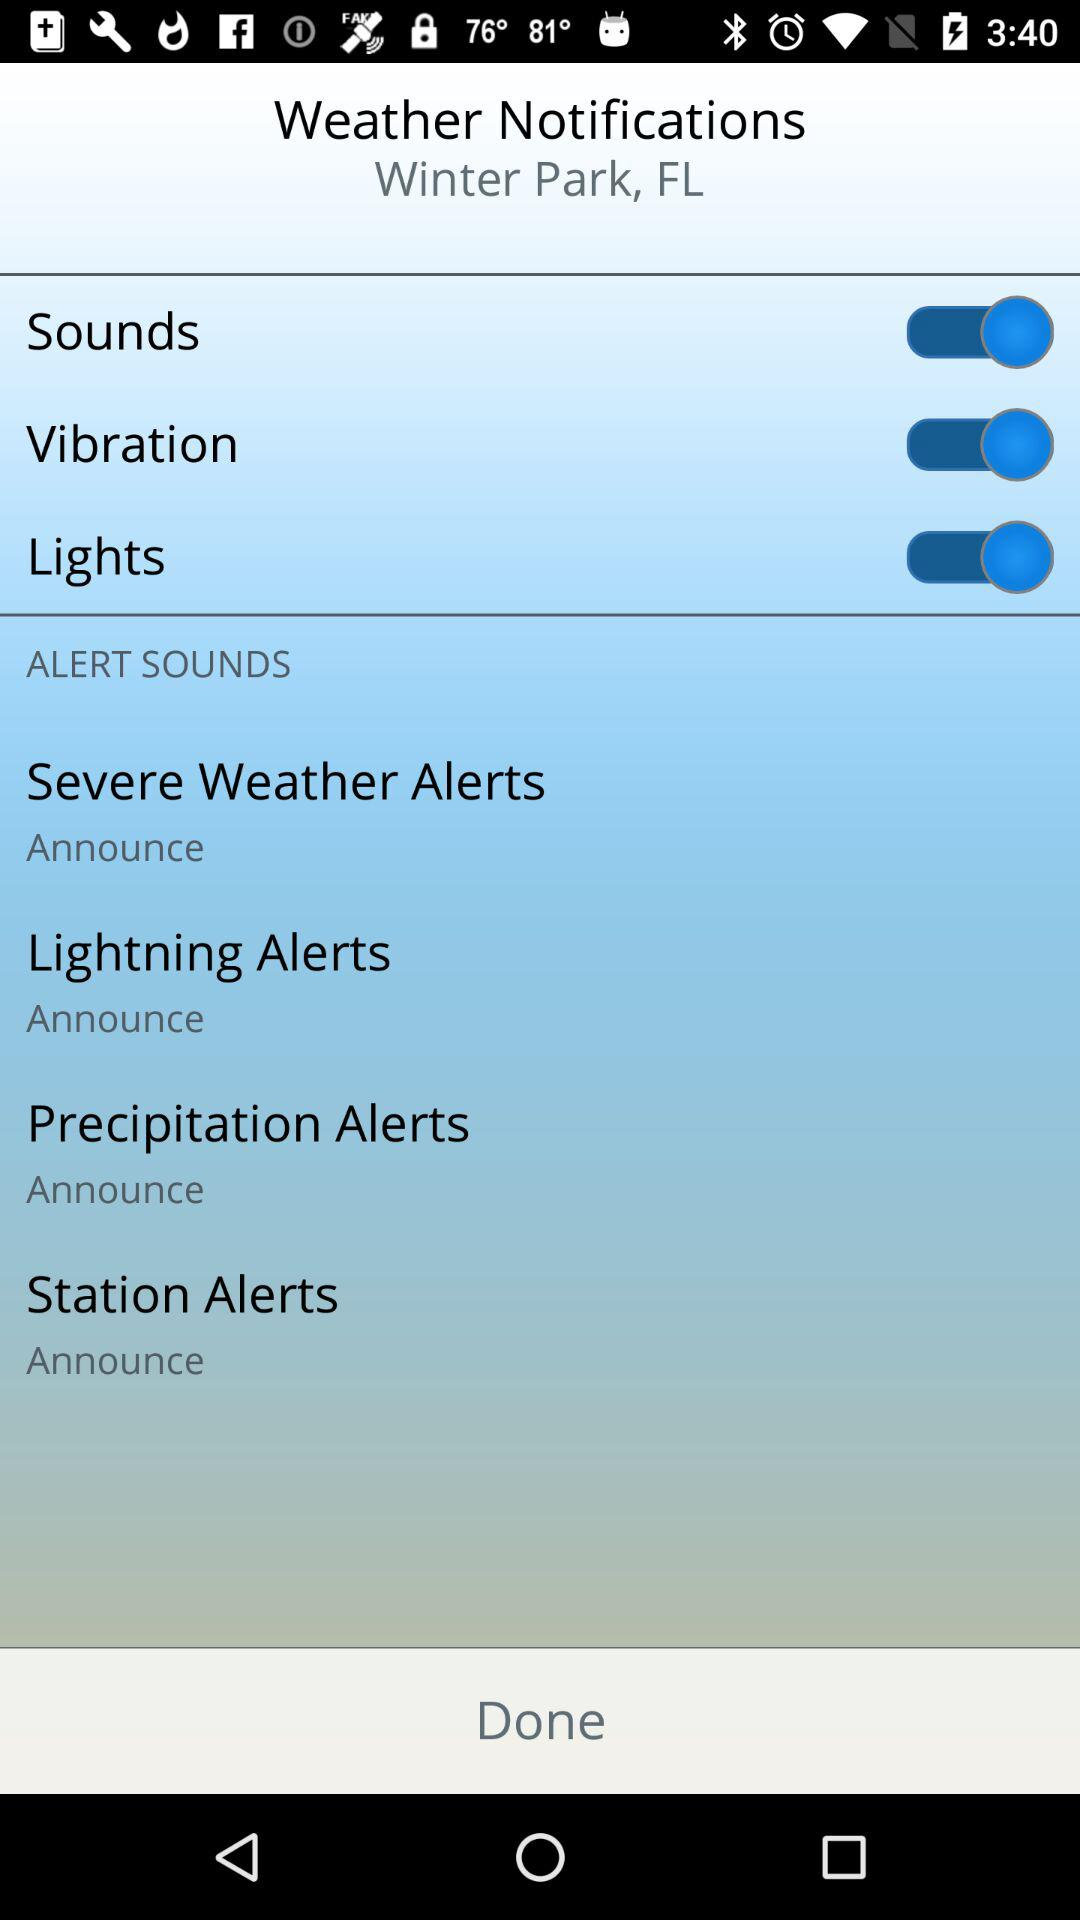What's the sound status of "Weather Notifications"? The status is "on". 